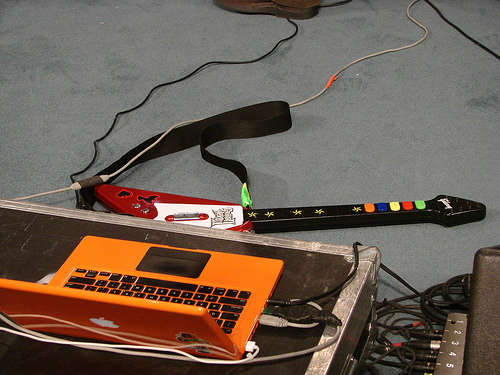<image>
Can you confirm if the cable wire is to the left of the laptop? No. The cable wire is not to the left of the laptop. From this viewpoint, they have a different horizontal relationship. 